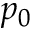Convert formula to latex. <formula><loc_0><loc_0><loc_500><loc_500>p _ { 0 }</formula> 